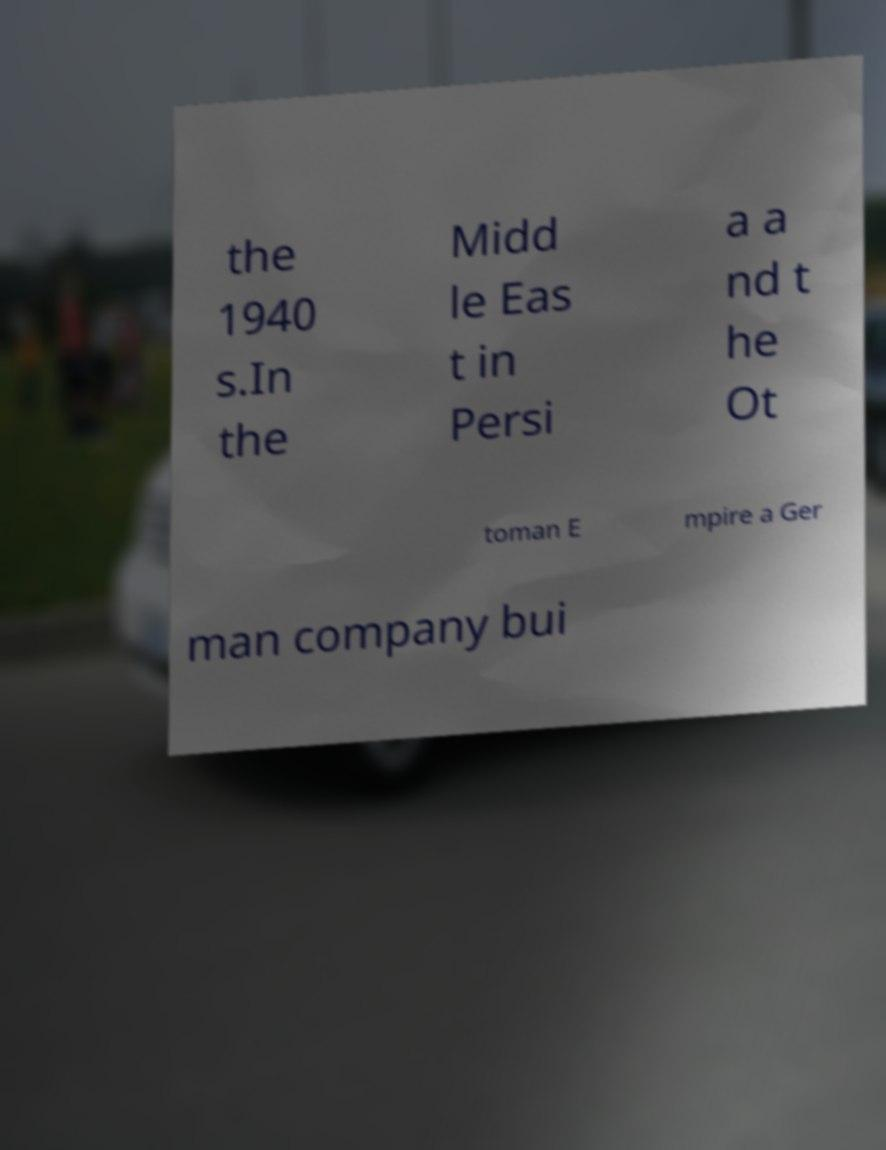Please read and relay the text visible in this image. What does it say? the 1940 s.In the Midd le Eas t in Persi a a nd t he Ot toman E mpire a Ger man company bui 